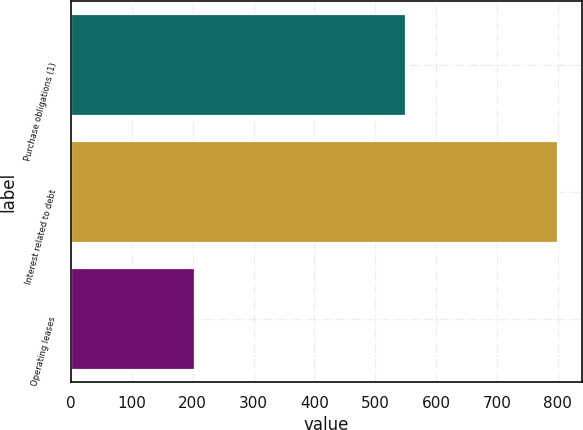<chart> <loc_0><loc_0><loc_500><loc_500><bar_chart><fcel>Purchase obligations (1)<fcel>Interest related to debt<fcel>Operating leases<nl><fcel>551<fcel>800<fcel>203<nl></chart> 